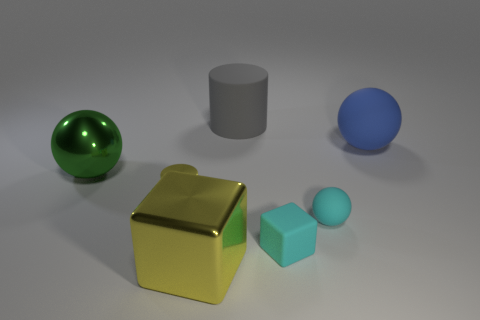Do the matte sphere behind the metal cylinder and the gray rubber cylinder have the same size?
Your answer should be compact. Yes. There is a big rubber thing behind the big matte ball; are there any rubber things that are behind it?
Your answer should be compact. No. How many metal things are behind the large object that is behind the large ball behind the green sphere?
Keep it short and to the point. 0. Are there fewer shiny cubes than big blue matte cylinders?
Ensure brevity in your answer.  No. There is a yellow metallic thing behind the metal block; is it the same shape as the big shiny object that is behind the small yellow thing?
Offer a terse response. No. What color is the big matte ball?
Give a very brief answer. Blue. What number of rubber objects are gray things or tiny objects?
Your answer should be compact. 3. What is the color of the metal thing that is the same shape as the gray matte object?
Your response must be concise. Yellow. Are there any big blue shiny cubes?
Offer a very short reply. No. Is the big thing to the right of the gray matte object made of the same material as the cylinder on the left side of the rubber cylinder?
Keep it short and to the point. No. 